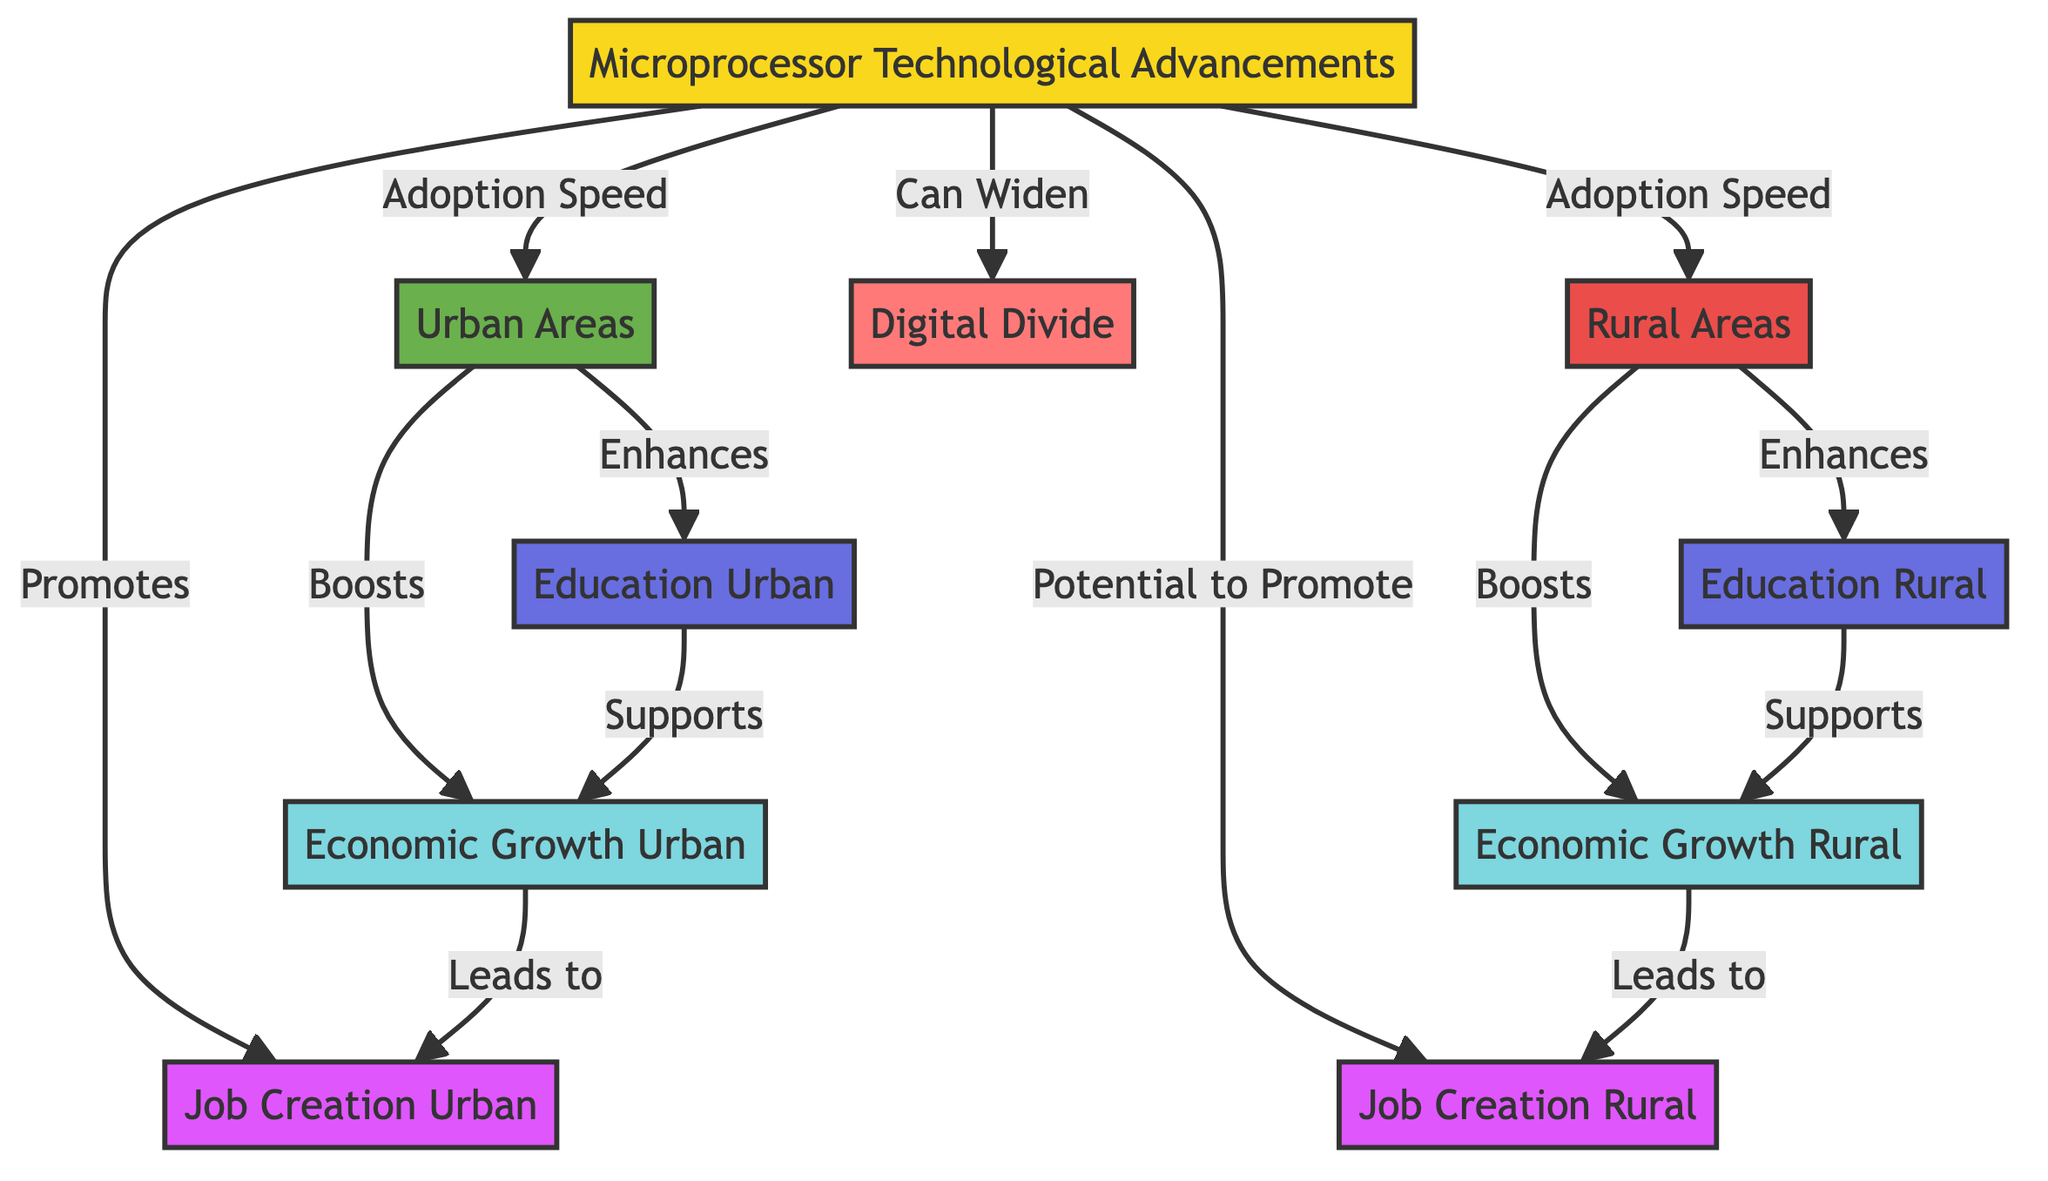What is the link between Microprocessor Technological Advancements and Urban Areas? The diagram shows that microprocessor technological advancements lead to adoption speed, which directly connects to urban areas. This indicates that advancements influence how quickly urban areas adopt these technologies.
Answer: Adoption Speed How many economic growth nodes are present in the diagram? By examining the diagram, there are two economic growth nodes identified: Economic Growth Urban and Economic Growth Rural.
Answer: 2 What effect does Urban Areas have on Job Creation Urban? Urban areas enhance economic growth, which subsequently leads to job creation in urban locales. The connection is established along the arrow from Urban Areas to Economic Growth Urban and then to Job Creation Urban.
Answer: Leads to Which area has the potential to promote job creation but is not guaranteed? The rural area is indicated to have the potential to promote job creation, but this is specified with a possible relation instead of a definite one, as depicted in the diagram.
Answer: Rural Areas How does Education in Urban Areas support Economic Growth Urban? The diagram indicates a direct relationship where education in urban areas supports economic growth urban, establishing a foundational link for sustained economic improvement.
Answer: Supports What can be inferred about the relationship between Microprocessor Technological Advancements and the Digital Divide? The diagram explicitly states that microprocessor technological advancements can widen the digital divide, suggesting that not all groups benefit equally from technological advancements, leading to disparities.
Answer: Can Widen What is the relationship between Job Creation Urban and Economic Growth Urban? The diagram depicts that job creation in urban areas is a consequence of economic growth in those same areas, highlighting an interdependent relationship where growth fuels job opportunities.
Answer: Leads to How does Economic Growth Rural connect to Job Creation Rural? Economic Growth Rural leads to Job Creation Rural as indicated by the arrow between these two nodes, illustrating a direct influence of rural economic progress on employment opportunities.
Answer: Leads to What type of areas have their education enhanced by Microprocessor Technological Advancements? Both urban and rural areas have their education enhanced as shown by the connections from microprocessor technological advancements leading to increased educational opportunities in these regions.
Answer: Urban and Rural Areas 